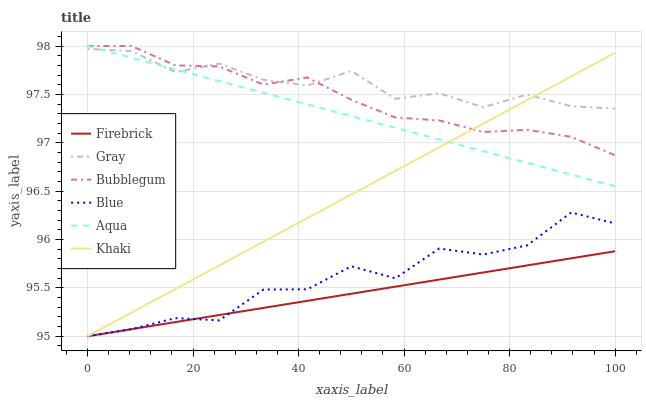Does Firebrick have the minimum area under the curve?
Answer yes or no. Yes. Does Gray have the maximum area under the curve?
Answer yes or no. Yes. Does Khaki have the minimum area under the curve?
Answer yes or no. No. Does Khaki have the maximum area under the curve?
Answer yes or no. No. Is Aqua the smoothest?
Answer yes or no. Yes. Is Blue the roughest?
Answer yes or no. Yes. Is Gray the smoothest?
Answer yes or no. No. Is Gray the roughest?
Answer yes or no. No. Does Blue have the lowest value?
Answer yes or no. Yes. Does Gray have the lowest value?
Answer yes or no. No. Does Bubblegum have the highest value?
Answer yes or no. Yes. Does Gray have the highest value?
Answer yes or no. No. Is Blue less than Aqua?
Answer yes or no. Yes. Is Bubblegum greater than Firebrick?
Answer yes or no. Yes. Does Aqua intersect Khaki?
Answer yes or no. Yes. Is Aqua less than Khaki?
Answer yes or no. No. Is Aqua greater than Khaki?
Answer yes or no. No. Does Blue intersect Aqua?
Answer yes or no. No. 